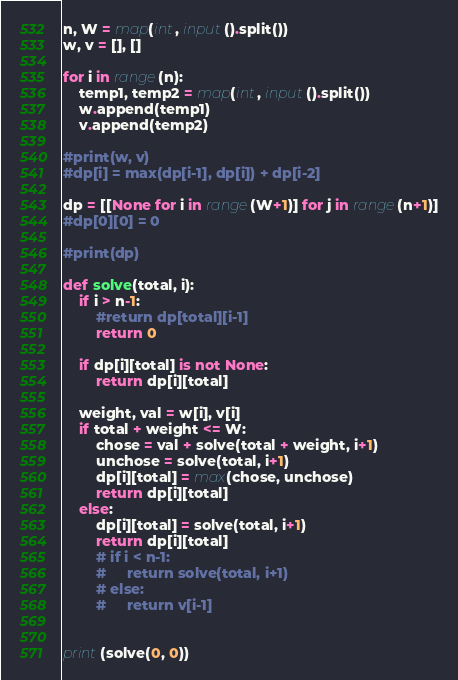<code> <loc_0><loc_0><loc_500><loc_500><_Python_>n, W = map(int, input().split())
w, v = [], []

for i in range(n):
    temp1, temp2 = map(int, input().split())
    w.append(temp1)
    v.append(temp2)

#print(w, v)
#dp[i] = max(dp[i-1], dp[i]) + dp[i-2]

dp = [[None for i in range(W+1)] for j in range(n+1)]
#dp[0][0] = 0

#print(dp)

def solve(total, i):
    if i > n-1:
        #return dp[total][i-1]
        return 0

    if dp[i][total] is not None:
        return dp[i][total]

    weight, val = w[i], v[i]
    if total + weight <= W:
        chose = val + solve(total + weight, i+1)
        unchose = solve(total, i+1)
        dp[i][total] = max(chose, unchose)
        return dp[i][total]
    else:
        dp[i][total] = solve(total, i+1)
        return dp[i][total]
        # if i < n-1:
        #     return solve(total, i+1)
        # else:
        #     return v[i-1]


print(solve(0, 0))</code> 